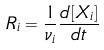<formula> <loc_0><loc_0><loc_500><loc_500>R _ { i } = \frac { 1 } { \nu _ { i } } \frac { d [ X _ { i } ] } { d t }</formula> 